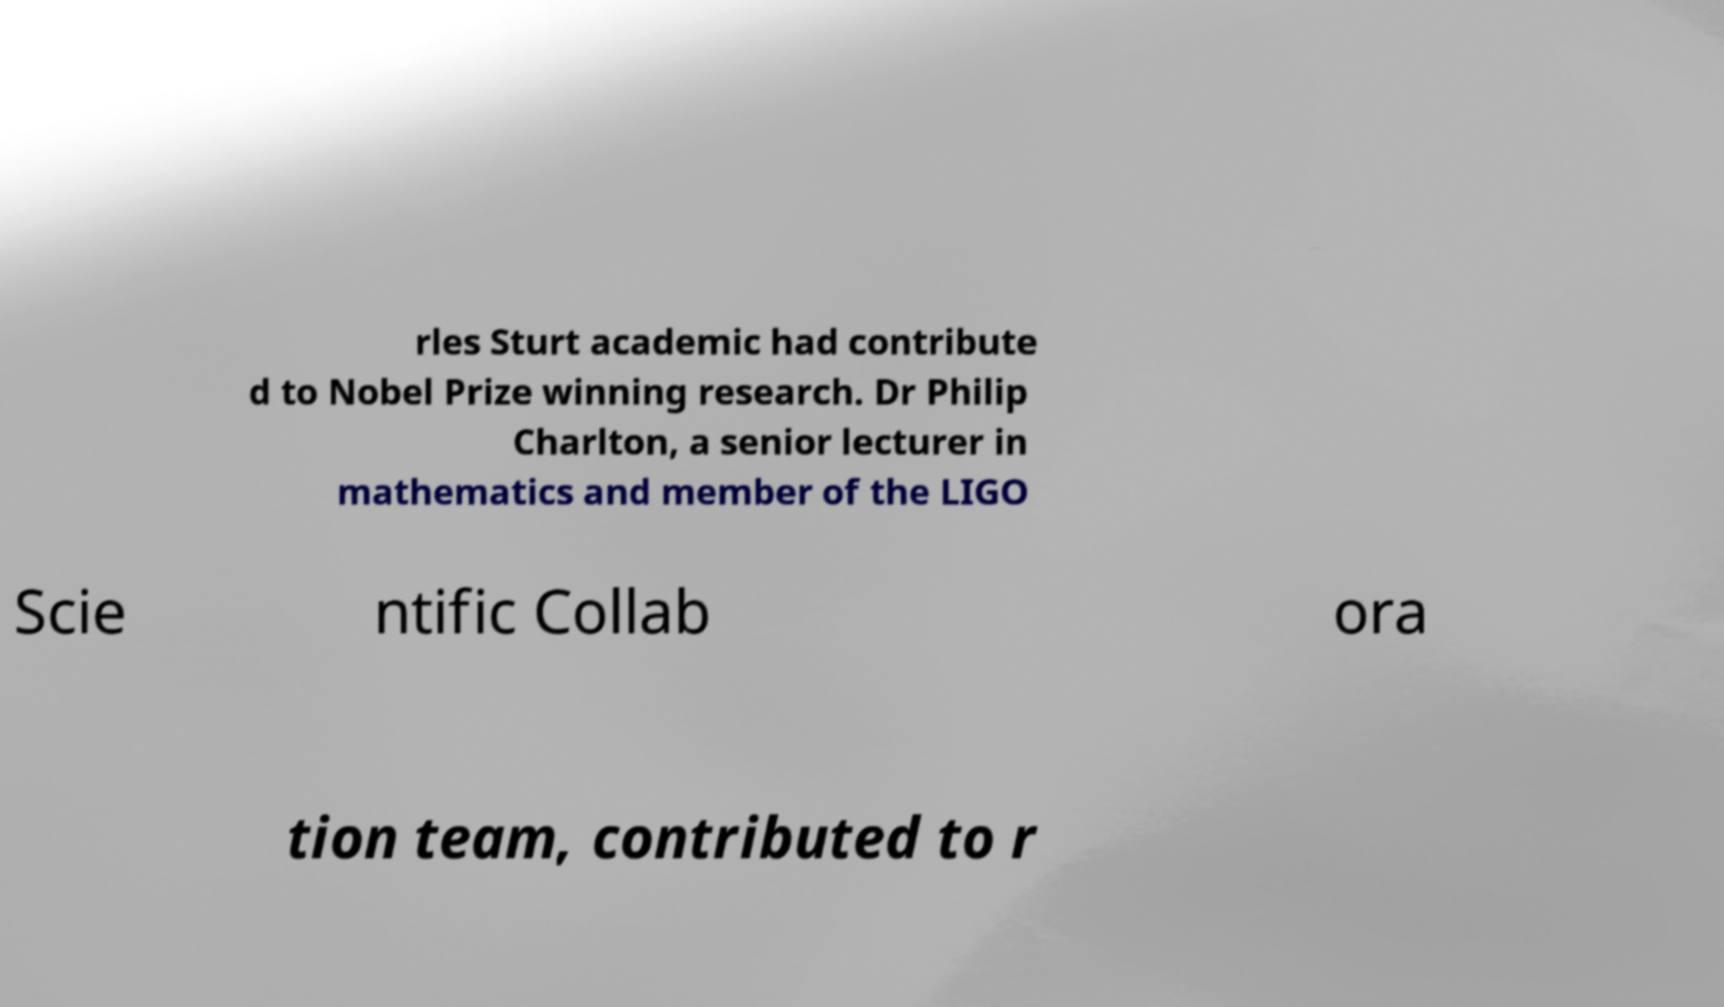Can you accurately transcribe the text from the provided image for me? rles Sturt academic had contribute d to Nobel Prize winning research. Dr Philip Charlton, a senior lecturer in mathematics and member of the LIGO Scie ntific Collab ora tion team, contributed to r 